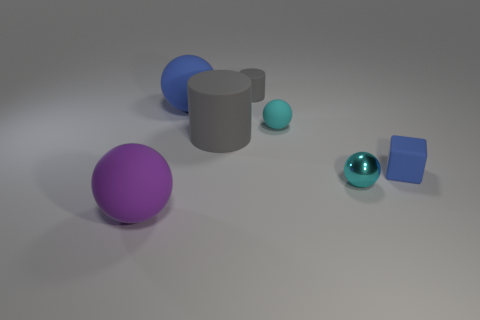There is a thing that is the same color as the small rubber sphere; what shape is it?
Make the answer very short. Sphere. Are there any other things that have the same shape as the small blue rubber thing?
Provide a short and direct response. No. What number of other things are there of the same size as the blue cube?
Your answer should be compact. 3. Do the blue thing that is on the left side of the cyan metallic ball and the cyan thing that is on the left side of the cyan metallic sphere have the same size?
Keep it short and to the point. No. How many things are either gray objects or blue objects to the right of the tiny matte sphere?
Your response must be concise. 3. There is a gray rubber object to the left of the tiny gray matte cylinder; what is its size?
Your answer should be very brief. Large. Are there fewer cyan things that are on the left side of the purple object than tiny objects in front of the large blue ball?
Give a very brief answer. Yes. There is a ball that is in front of the large matte cylinder and on the right side of the big matte cylinder; what material is it?
Ensure brevity in your answer.  Metal. There is a gray thing in front of the gray rubber cylinder that is behind the big blue object; what is its shape?
Your answer should be very brief. Cylinder. Is the color of the metallic object the same as the tiny matte sphere?
Provide a succinct answer. Yes. 